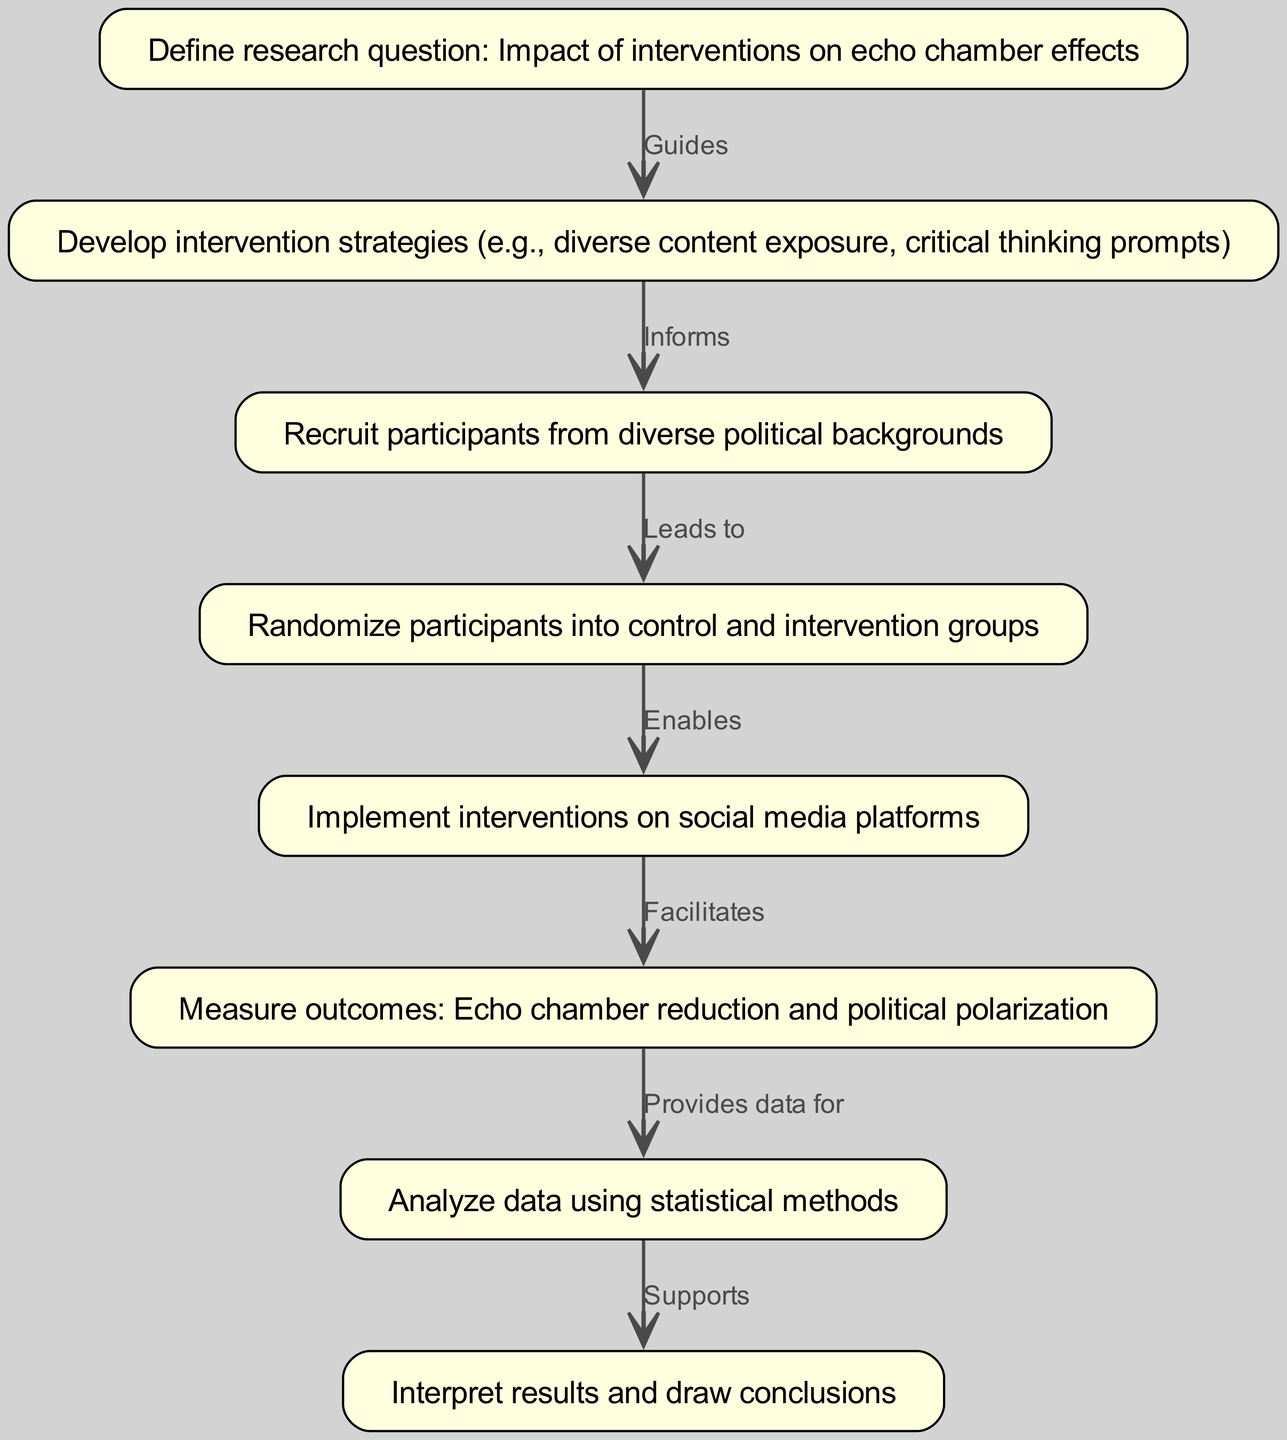What is the first step in the pathway? The diagram indicates that the first step is defining the research question, specifically focused on the impact of interventions on echo chamber effects. This is the initial node in the clinical pathway.
Answer: Define research question: Impact of interventions on echo chamber effects How many nodes are there in the diagram? By counting the nodes listed in the data, there are a total of 8 distinct nodes represented in the clinical pathway.
Answer: 8 What relationship does node 3 have with node 4? The relationship between node 3 (Recruit participants from diverse political backgrounds) and node 4 (Randomize participants into control and intervention groups) is labeled as "Leads to." This indicates that completing the third step naturally progresses to the fourth step.
Answer: Leads to What is the last step of the clinical pathway? The last step in the pathway is interpreting the results and drawing conclusions based on the data analyzed. This is the eighth node in the sequence.
Answer: Interpret results and draw conclusions Which step facilitates measuring outcomes? The step that facilitates measuring outcomes, specifically regarding echo chamber reduction and political polarization, is the implementation of the interventions on social media platforms. This is indicated by the arrow from the fifth node to the sixth node.
Answer: Implement interventions on social media platforms What provides data for the analysis in this pathway? The outcomes measured in the sixth step (echo chamber reduction and political polarization) provide the necessary data for the analysis performed in step seven, which involves statistical methods.
Answer: Measure outcomes: Echo chamber reduction and political polarization What do the interventions aim to do? The interventions aim to reduce echo chamber effects. This is outlined in the step where the intervention strategies are developed.
Answer: Reduce echo chamber effects How does developing intervention strategies relate to recruiting participants? Developing intervention strategies informs the process of recruiting participants, as the strategies must align with the diverse backgrounds of the targeted participants in the study.
Answer: Informs 